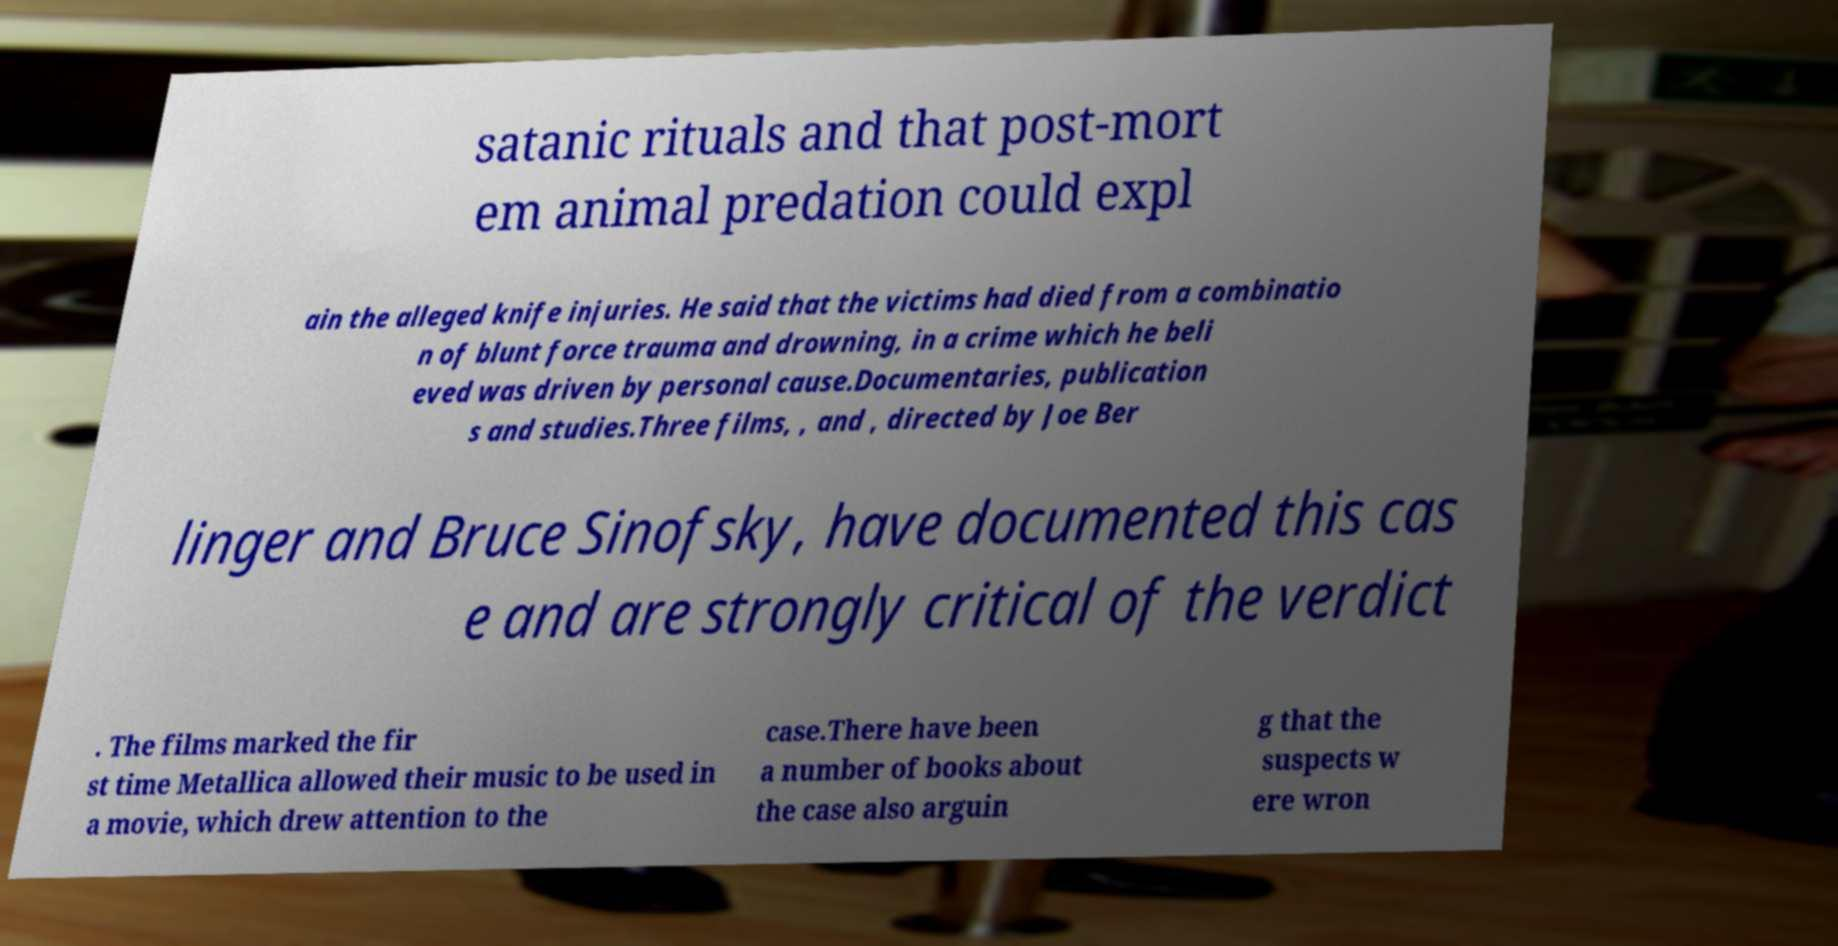What messages or text are displayed in this image? I need them in a readable, typed format. satanic rituals and that post-mort em animal predation could expl ain the alleged knife injuries. He said that the victims had died from a combinatio n of blunt force trauma and drowning, in a crime which he beli eved was driven by personal cause.Documentaries, publication s and studies.Three films, , and , directed by Joe Ber linger and Bruce Sinofsky, have documented this cas e and are strongly critical of the verdict . The films marked the fir st time Metallica allowed their music to be used in a movie, which drew attention to the case.There have been a number of books about the case also arguin g that the suspects w ere wron 